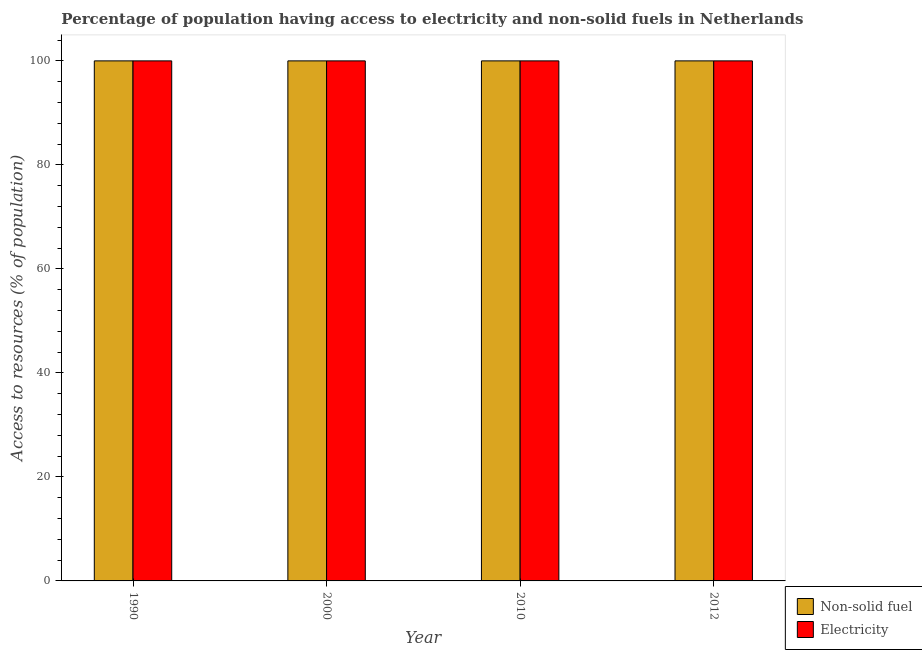How many different coloured bars are there?
Provide a succinct answer. 2. How many groups of bars are there?
Offer a very short reply. 4. How many bars are there on the 2nd tick from the left?
Provide a succinct answer. 2. What is the label of the 4th group of bars from the left?
Your answer should be compact. 2012. What is the percentage of population having access to electricity in 2010?
Offer a terse response. 100. Across all years, what is the maximum percentage of population having access to non-solid fuel?
Offer a terse response. 100. Across all years, what is the minimum percentage of population having access to electricity?
Your answer should be very brief. 100. In which year was the percentage of population having access to electricity minimum?
Give a very brief answer. 1990. What is the total percentage of population having access to electricity in the graph?
Make the answer very short. 400. What is the ratio of the percentage of population having access to electricity in 1990 to that in 2010?
Your answer should be compact. 1. Is the percentage of population having access to non-solid fuel in 1990 less than that in 2012?
Your answer should be very brief. No. What is the difference between the highest and the second highest percentage of population having access to electricity?
Provide a short and direct response. 0. What is the difference between the highest and the lowest percentage of population having access to electricity?
Provide a short and direct response. 0. In how many years, is the percentage of population having access to non-solid fuel greater than the average percentage of population having access to non-solid fuel taken over all years?
Provide a succinct answer. 0. Is the sum of the percentage of population having access to non-solid fuel in 1990 and 2012 greater than the maximum percentage of population having access to electricity across all years?
Your answer should be compact. Yes. What does the 1st bar from the left in 1990 represents?
Your answer should be compact. Non-solid fuel. What does the 2nd bar from the right in 1990 represents?
Give a very brief answer. Non-solid fuel. How many bars are there?
Provide a short and direct response. 8. How many years are there in the graph?
Provide a succinct answer. 4. Are the values on the major ticks of Y-axis written in scientific E-notation?
Ensure brevity in your answer.  No. Does the graph contain any zero values?
Provide a succinct answer. No. Does the graph contain grids?
Provide a succinct answer. No. What is the title of the graph?
Ensure brevity in your answer.  Percentage of population having access to electricity and non-solid fuels in Netherlands. Does "Non-pregnant women" appear as one of the legend labels in the graph?
Your response must be concise. No. What is the label or title of the X-axis?
Provide a succinct answer. Year. What is the label or title of the Y-axis?
Keep it short and to the point. Access to resources (% of population). What is the Access to resources (% of population) of Non-solid fuel in 1990?
Provide a succinct answer. 100. What is the Access to resources (% of population) in Electricity in 2010?
Provide a short and direct response. 100. What is the difference between the Access to resources (% of population) of Non-solid fuel in 1990 and that in 2000?
Provide a short and direct response. 0. What is the difference between the Access to resources (% of population) in Non-solid fuel in 1990 and that in 2010?
Ensure brevity in your answer.  0. What is the difference between the Access to resources (% of population) in Electricity in 1990 and that in 2010?
Make the answer very short. 0. What is the difference between the Access to resources (% of population) in Non-solid fuel in 1990 and that in 2012?
Make the answer very short. 0. What is the difference between the Access to resources (% of population) in Non-solid fuel in 2000 and that in 2010?
Give a very brief answer. 0. What is the difference between the Access to resources (% of population) in Non-solid fuel in 2000 and that in 2012?
Provide a short and direct response. 0. What is the difference between the Access to resources (% of population) of Non-solid fuel in 2010 and that in 2012?
Keep it short and to the point. 0. What is the difference between the Access to resources (% of population) of Electricity in 2010 and that in 2012?
Offer a very short reply. 0. What is the difference between the Access to resources (% of population) in Non-solid fuel in 1990 and the Access to resources (% of population) in Electricity in 2010?
Your response must be concise. 0. What is the difference between the Access to resources (% of population) in Non-solid fuel in 1990 and the Access to resources (% of population) in Electricity in 2012?
Offer a very short reply. 0. What is the difference between the Access to resources (% of population) of Non-solid fuel in 2010 and the Access to resources (% of population) of Electricity in 2012?
Give a very brief answer. 0. What is the average Access to resources (% of population) of Non-solid fuel per year?
Give a very brief answer. 100. What is the average Access to resources (% of population) of Electricity per year?
Give a very brief answer. 100. In the year 2000, what is the difference between the Access to resources (% of population) in Non-solid fuel and Access to resources (% of population) in Electricity?
Provide a short and direct response. 0. In the year 2010, what is the difference between the Access to resources (% of population) of Non-solid fuel and Access to resources (% of population) of Electricity?
Provide a short and direct response. 0. In the year 2012, what is the difference between the Access to resources (% of population) of Non-solid fuel and Access to resources (% of population) of Electricity?
Keep it short and to the point. 0. What is the ratio of the Access to resources (% of population) of Electricity in 1990 to that in 2000?
Your answer should be compact. 1. What is the ratio of the Access to resources (% of population) of Non-solid fuel in 1990 to that in 2012?
Offer a very short reply. 1. What is the ratio of the Access to resources (% of population) of Non-solid fuel in 2000 to that in 2010?
Provide a short and direct response. 1. What is the ratio of the Access to resources (% of population) of Electricity in 2000 to that in 2010?
Keep it short and to the point. 1. What is the ratio of the Access to resources (% of population) in Non-solid fuel in 2000 to that in 2012?
Your response must be concise. 1. What is the ratio of the Access to resources (% of population) of Non-solid fuel in 2010 to that in 2012?
Keep it short and to the point. 1. What is the difference between the highest and the second highest Access to resources (% of population) in Non-solid fuel?
Offer a terse response. 0. What is the difference between the highest and the second highest Access to resources (% of population) in Electricity?
Offer a terse response. 0. What is the difference between the highest and the lowest Access to resources (% of population) of Non-solid fuel?
Give a very brief answer. 0. What is the difference between the highest and the lowest Access to resources (% of population) in Electricity?
Offer a very short reply. 0. 